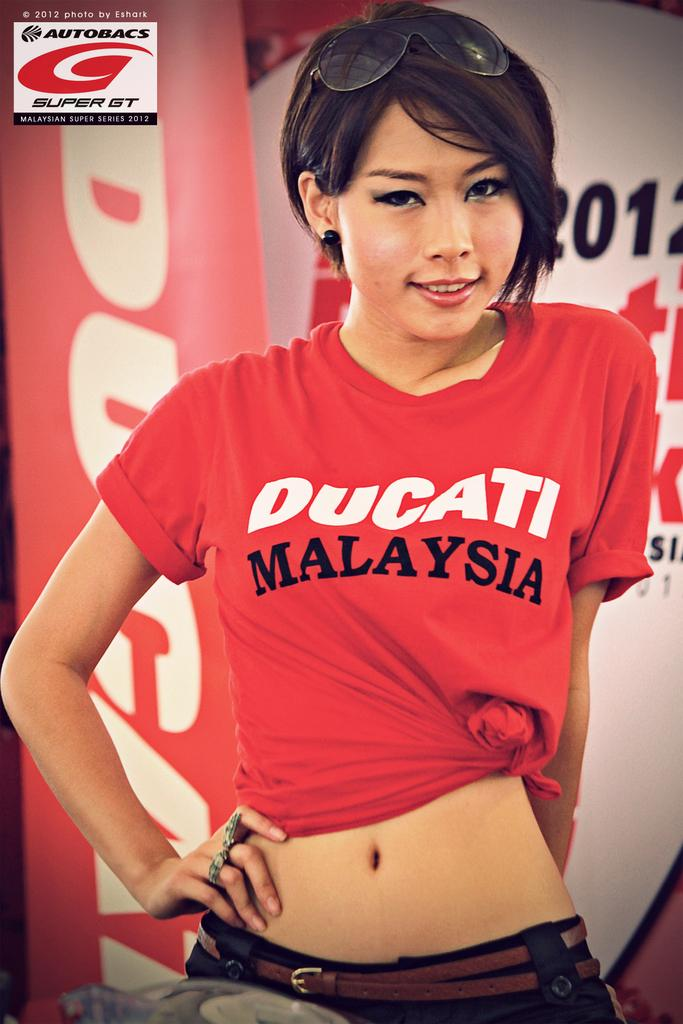<image>
Relay a brief, clear account of the picture shown. Female standing in front of a banner that has Malaysian super series 2012 in white. 